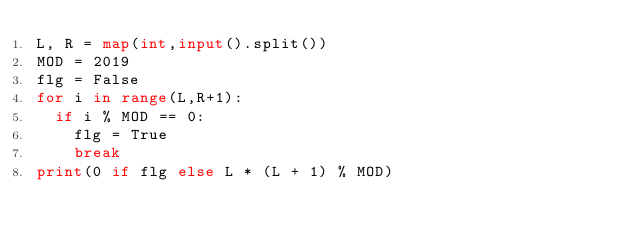Convert code to text. <code><loc_0><loc_0><loc_500><loc_500><_Python_>L, R = map(int,input().split())
MOD = 2019
flg = False
for i in range(L,R+1):
  if i % MOD == 0:
    flg = True
    break
print(0 if flg else L * (L + 1) % MOD)</code> 